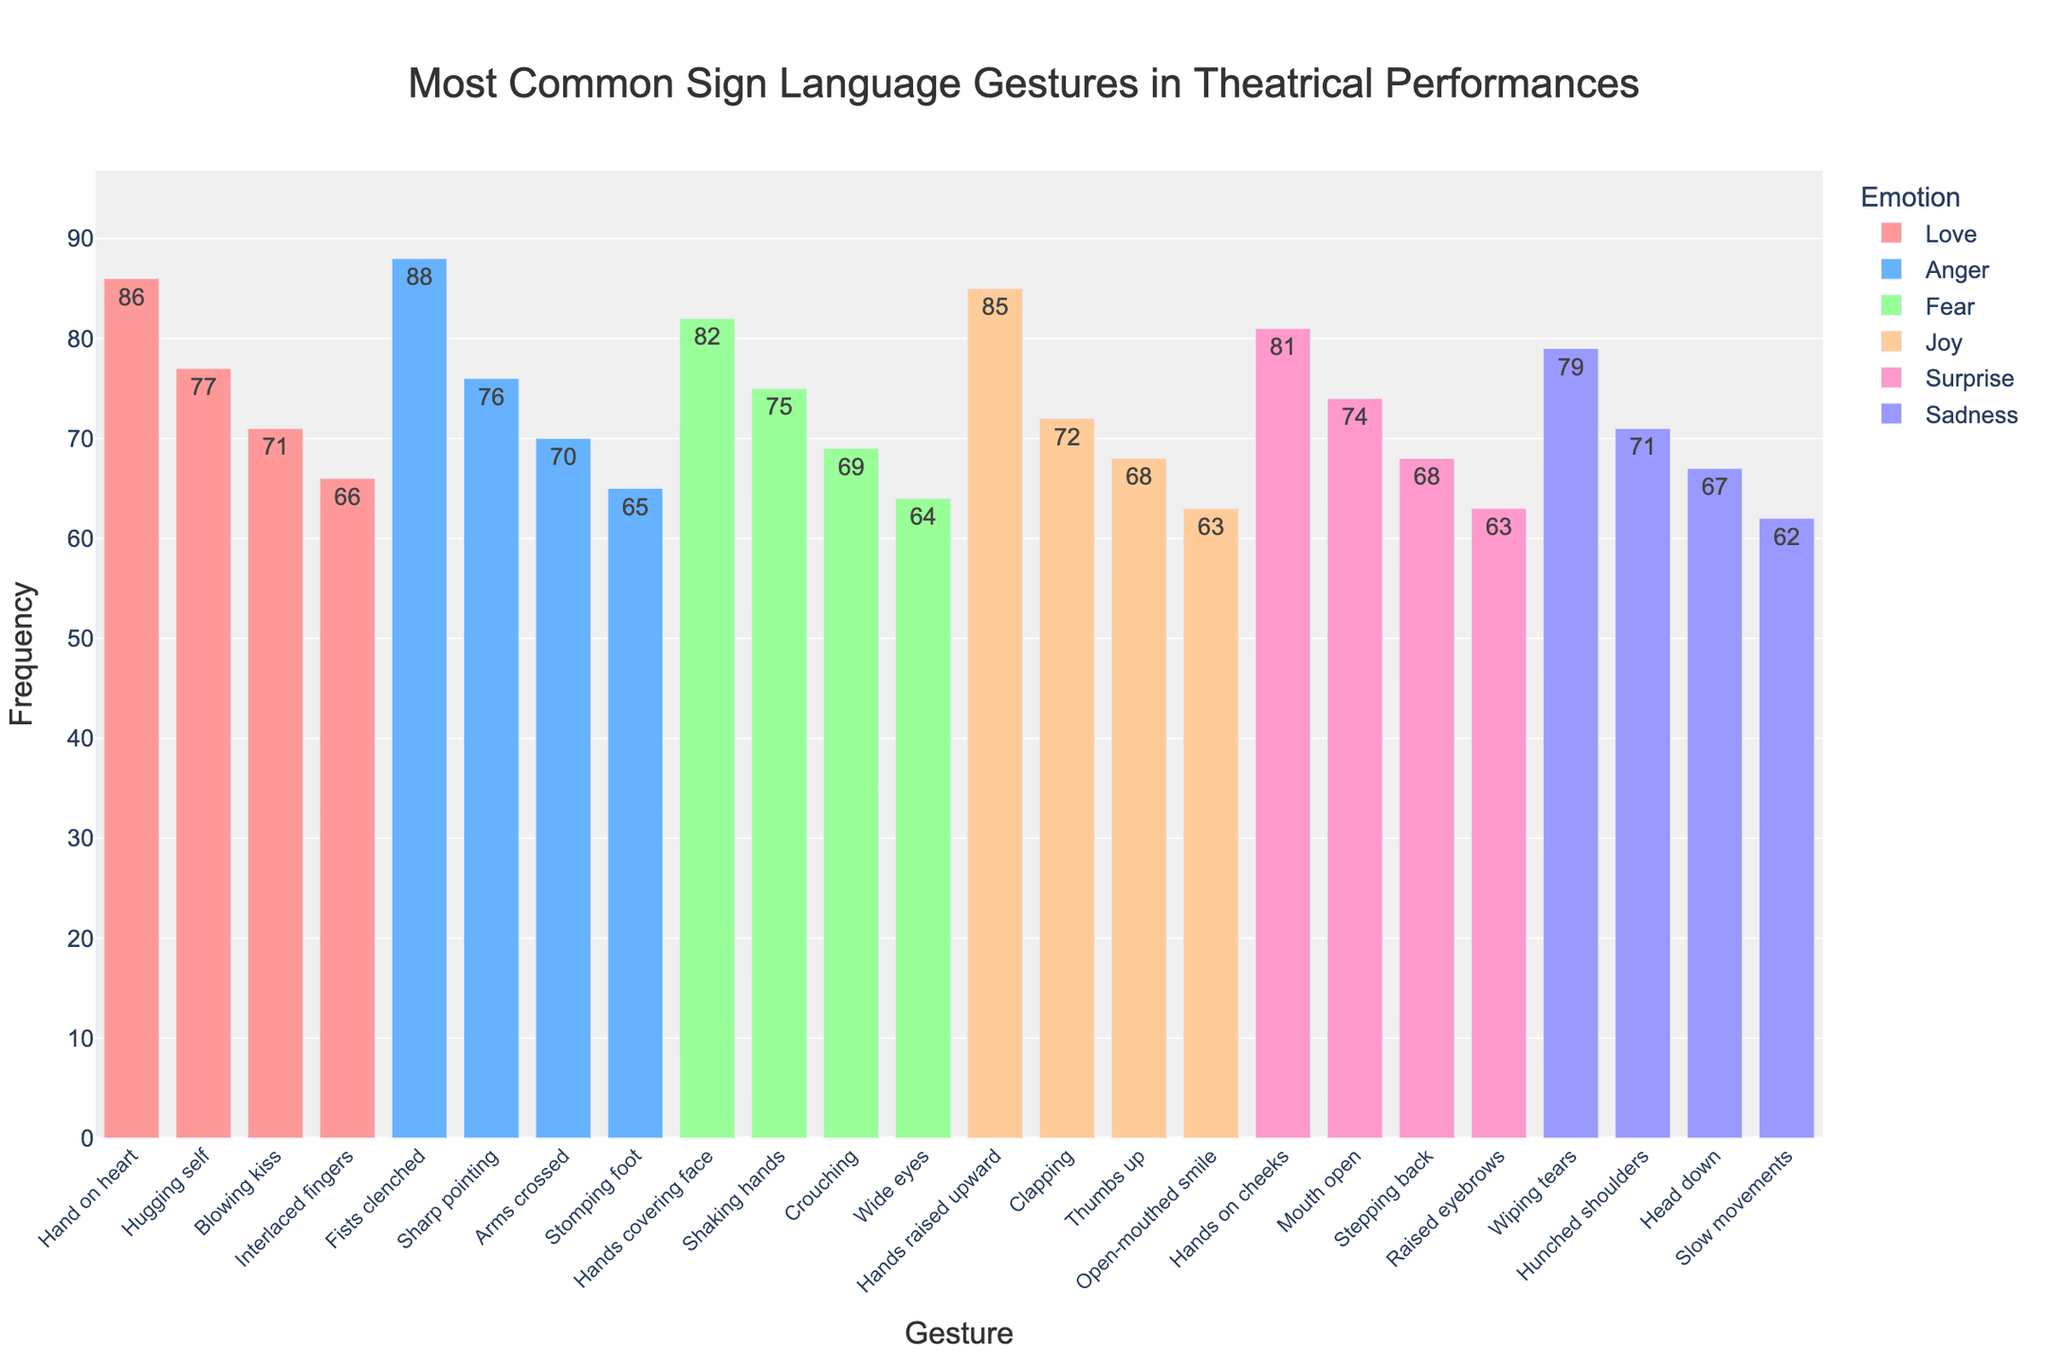Which emotion has the gesture with the highest frequency overall? The figure shows bars for different gestures under each emotion. The highest bar is for the gesture "Fists clenched" under the emotion "Anger" with a frequency of 88.
Answer: Anger What is the total frequency of gestures associated with "Joy"? To find the total frequency for Joy, sum the frequencies of all four gestures under Joy: 85 (Hands raised upward) + 72 (Clapping) + 68 (Thumbs up) + 63 (Open-mouthed smile) = 288.
Answer: 288 Which gesture and emotion combination has the lowest frequency? By observing the shortest bar in the figure, we see that "Slow movements" under "Sadness" has the lowest frequency of 62.
Answer: Slow movements, Sadness Compare the frequencies of the "Hands covering face" gesture and the "Hugging self" gesture. Which one is more common and by how much? The "Hands covering face" gesture (under Fear) has a frequency of 82, while the "Hugging self" gesture (under Love) has a frequency of 77. The difference is 82 - 77 = 5.
Answer: Hands covering face, by 5 What is the average frequency of the gestures associated with the emotion "Surprise"? The frequencies for Surprise are 81 (Hands on cheeks) + 74 (Mouth open) + 68 (Stepping back) + 63 (Raised eyebrows). Sum these values to get 286. To find the average, divide by 4 (the number of gestures): 286 / 4 = 71.5.
Answer: 71.5 Which emotion has the greatest total frequency of gestures and what is it? Sum the frequencies of all gestures under each emotion, then compare the totals. Anger has the greatest total with 88 (Fists clenched) + 76 (Sharp pointing) + 70 (Arms crossed) + 65 (Stomping foot) = 299.
Answer: Anger How much more frequent is the "Hand on heart" gesture compared to the "Wide eyes" gesture? The "Hand on heart" gesture (under Love) has a frequency of 86, while the "Wide eyes" gesture (under Fear) has a frequency of 64. The difference is 86 - 64 = 22.
Answer: 22 Which gestures under "Fear" have higher frequencies than "Thumbs up" under "Joy"? "Thumbs up" under Joy has a frequency of 68. Under Fear, "Hands covering face" (82), "Shaking hands" (75), and "Crouching" (69) all have higher frequencies than 68.
Answer: Hands covering face, Shaking hands, Crouching 